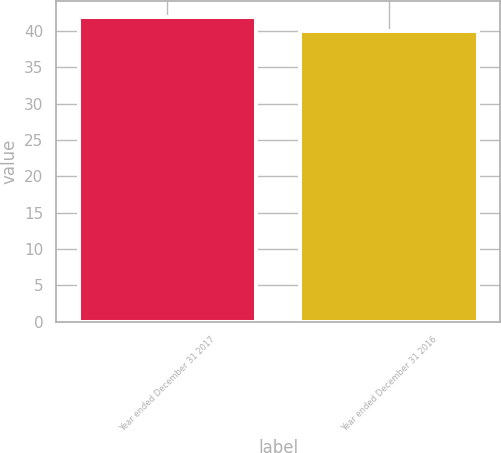<chart> <loc_0><loc_0><loc_500><loc_500><bar_chart><fcel>Year ended December 31 2017<fcel>Year ended December 31 2016<nl><fcel>42<fcel>40<nl></chart> 